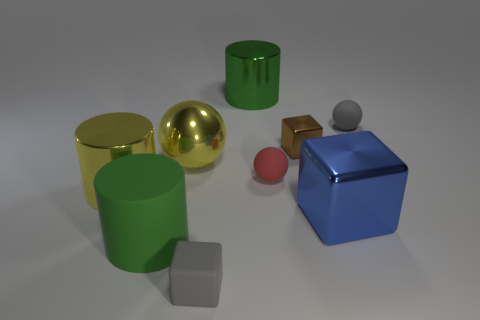Subtract all big green cylinders. How many cylinders are left? 1 Add 1 red matte objects. How many objects exist? 10 Subtract all red balls. How many balls are left? 2 Subtract all cubes. How many objects are left? 6 Subtract 2 cubes. How many cubes are left? 1 Subtract all brown shiny blocks. Subtract all big things. How many objects are left? 3 Add 5 spheres. How many spheres are left? 8 Add 8 yellow balls. How many yellow balls exist? 9 Subtract 0 purple cylinders. How many objects are left? 9 Subtract all yellow cylinders. Subtract all purple balls. How many cylinders are left? 2 